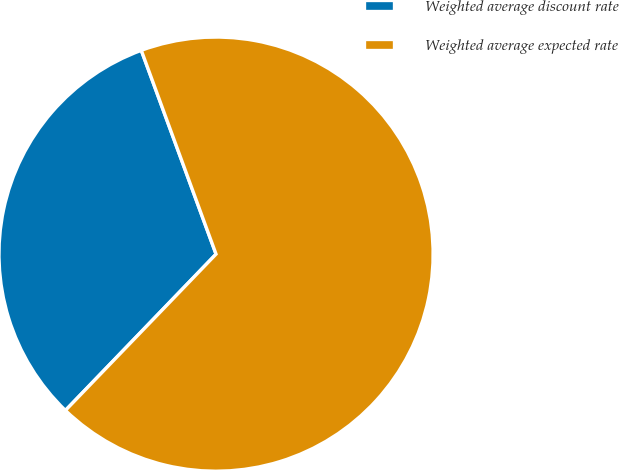Convert chart. <chart><loc_0><loc_0><loc_500><loc_500><pie_chart><fcel>Weighted average discount rate<fcel>Weighted average expected rate<nl><fcel>32.2%<fcel>67.8%<nl></chart> 